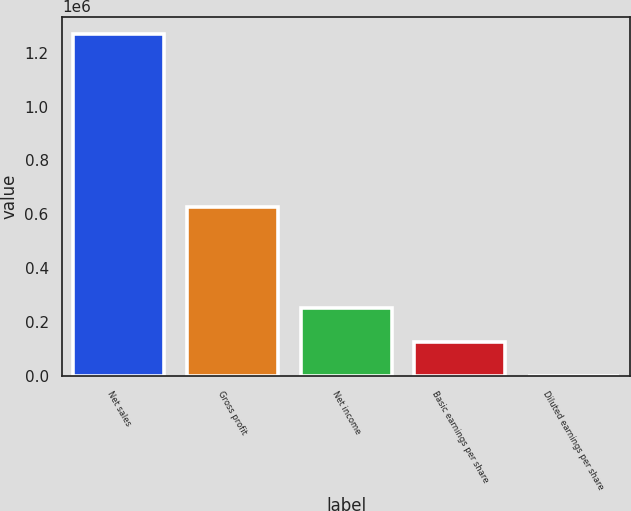Convert chart to OTSL. <chart><loc_0><loc_0><loc_500><loc_500><bar_chart><fcel>Net sales<fcel>Gross profit<fcel>Net income<fcel>Basic earnings per share<fcel>Diluted earnings per share<nl><fcel>1.27013e+06<fcel>627485<fcel>254026<fcel>127014<fcel>0.57<nl></chart> 